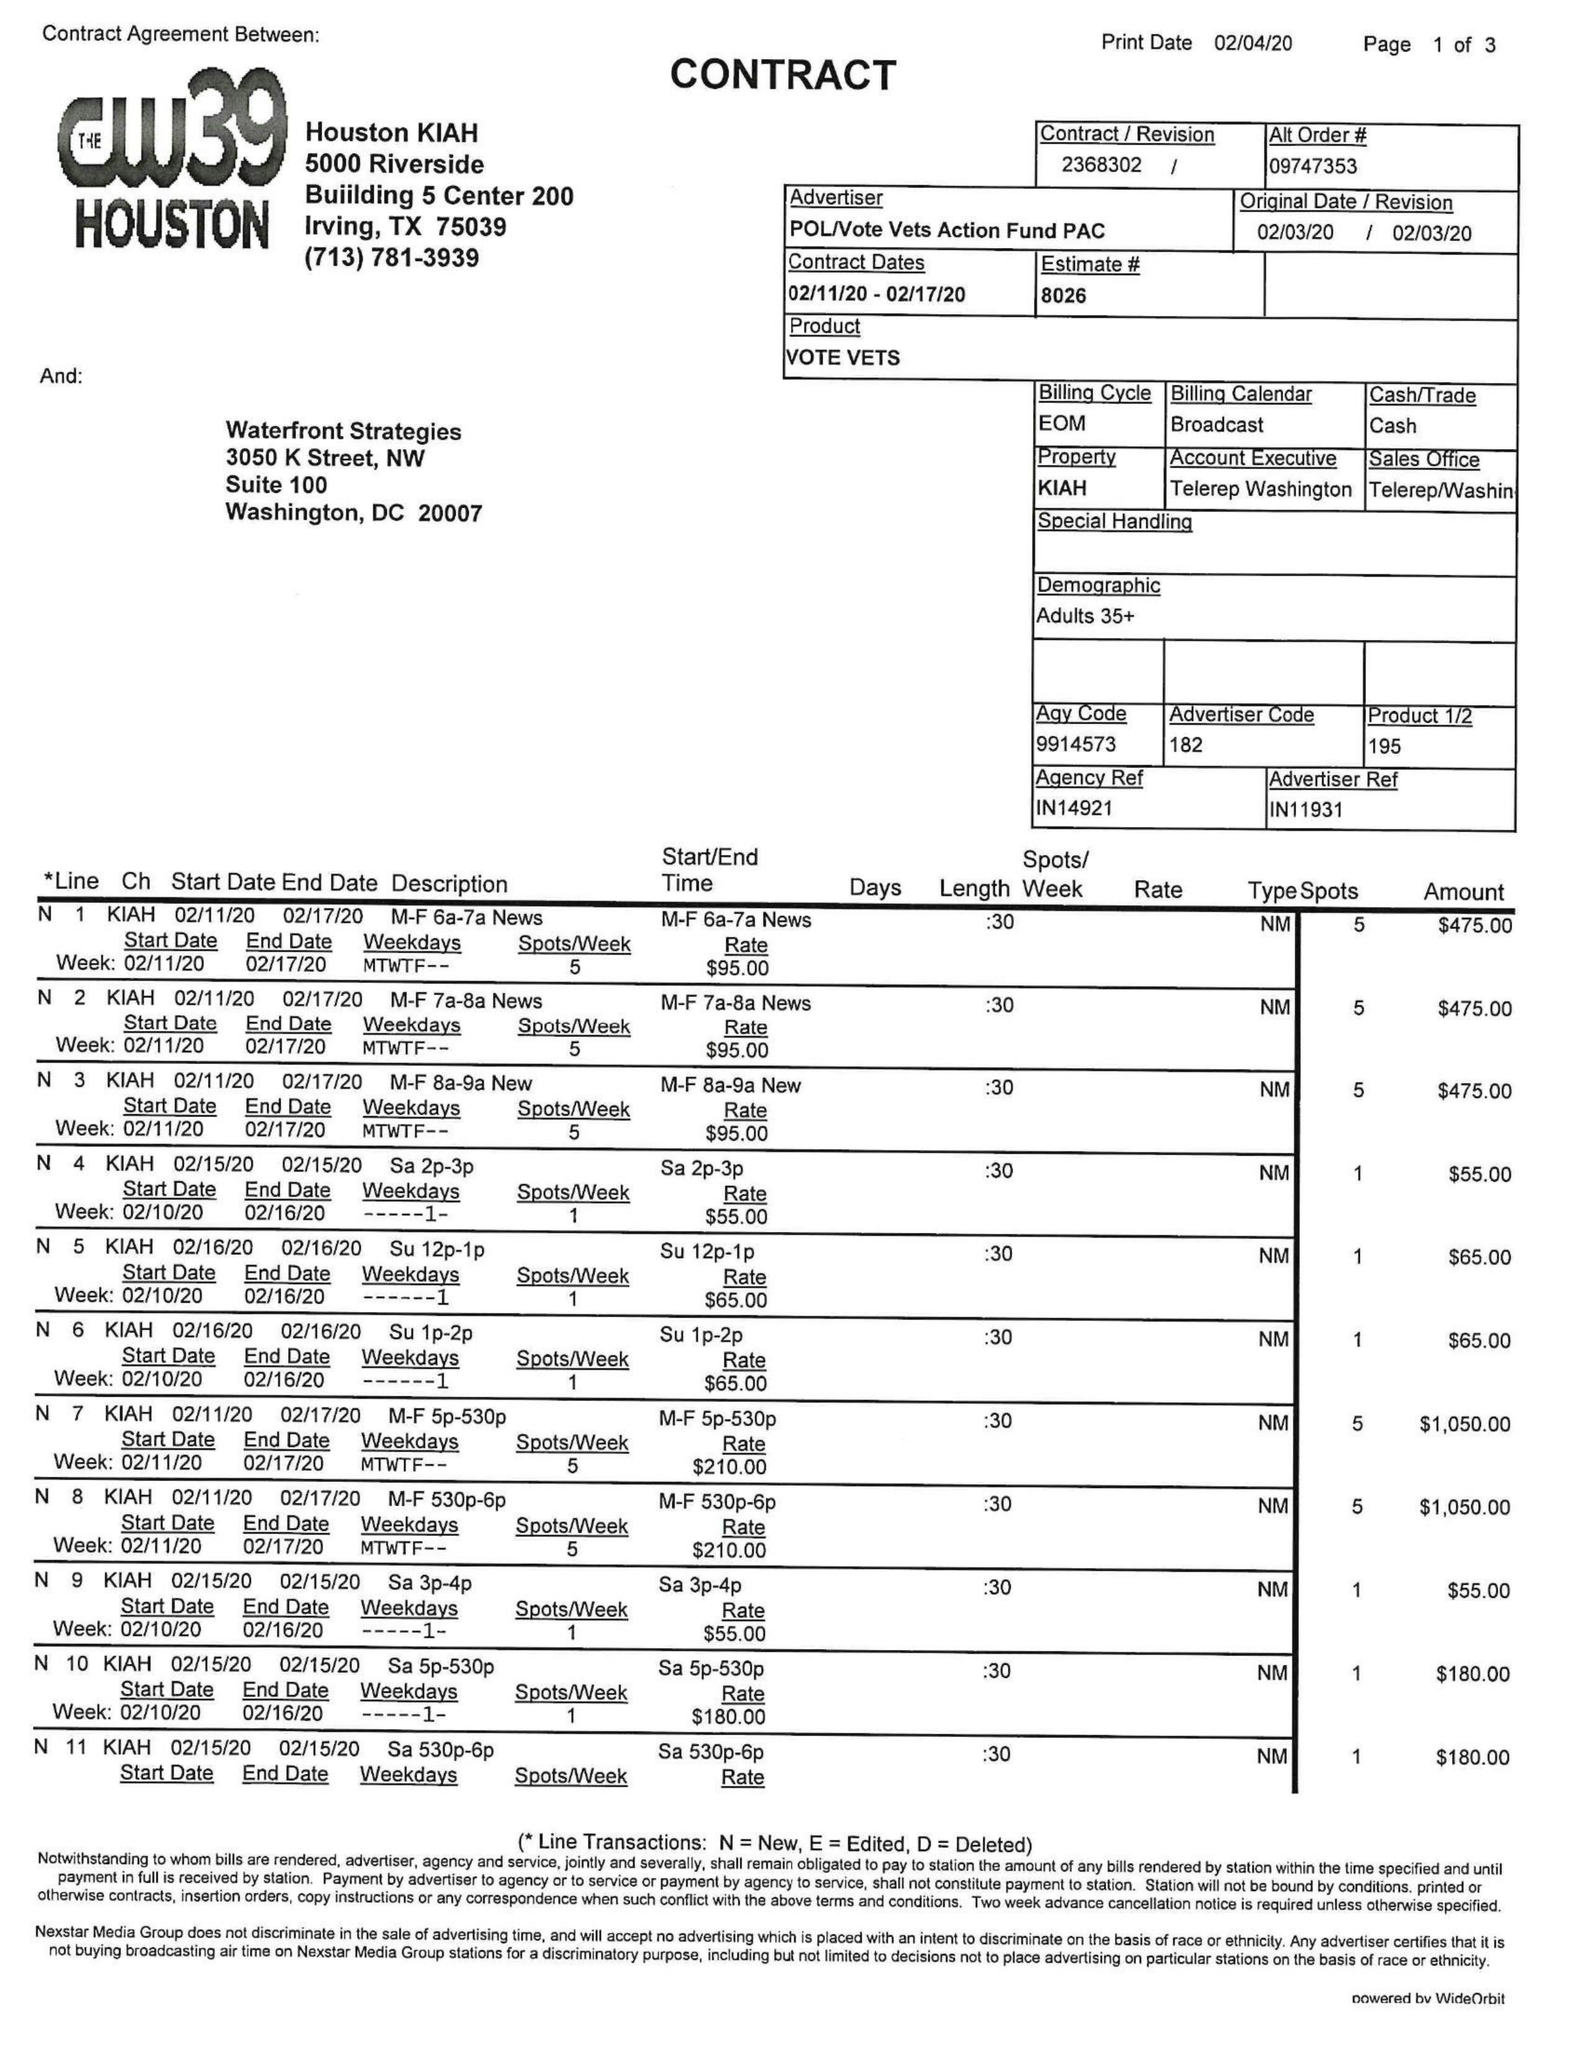What is the value for the contract_num?
Answer the question using a single word or phrase. 2368302 